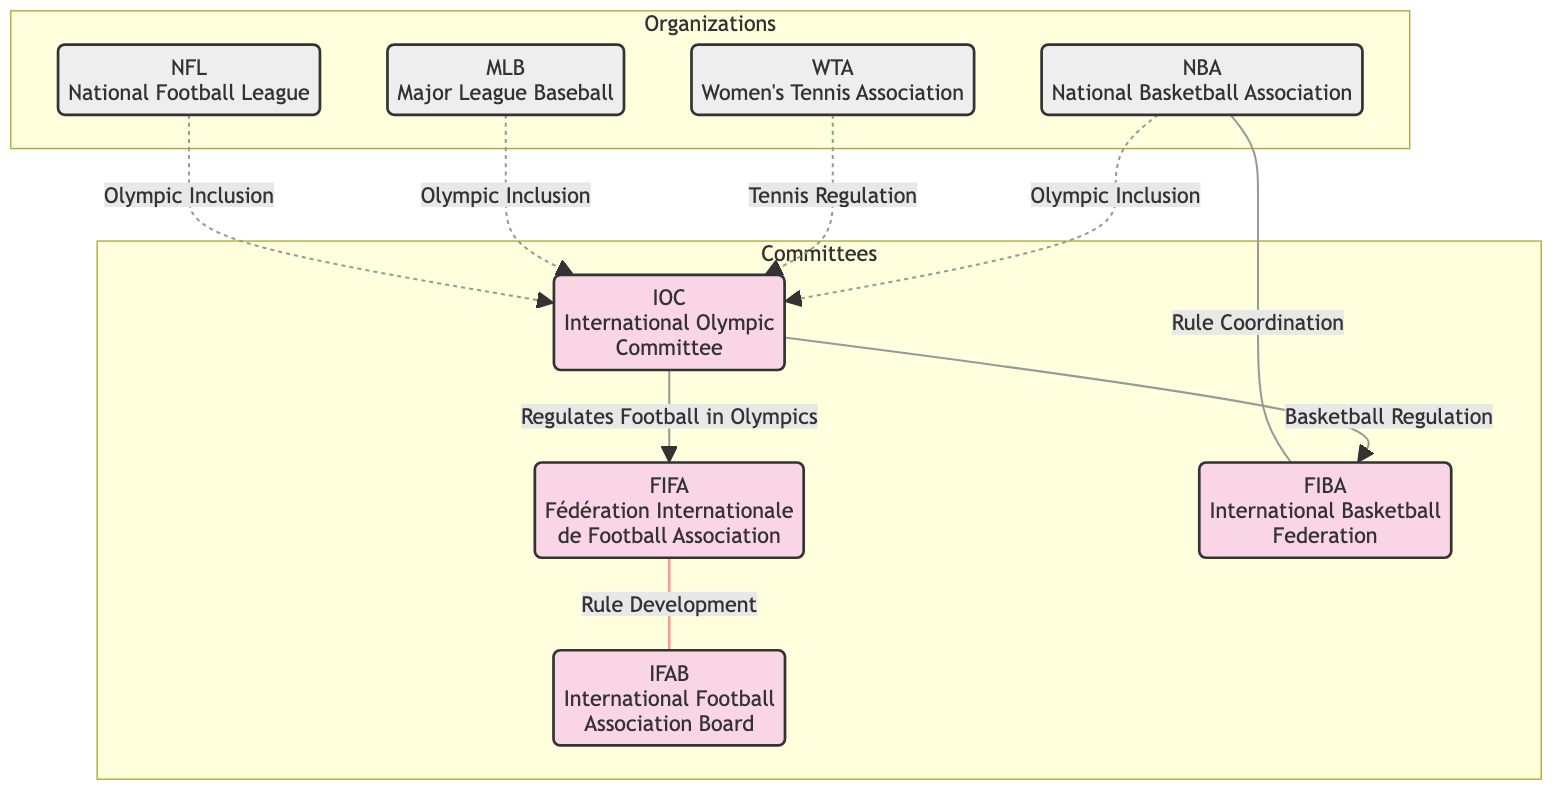What is the total number of nodes in the diagram? The diagram lists 8 distinct nodes, which include 4 committees and 4 organizations. Counting them gives us 1 (FIFA), 2 (IFAB), 3 (IOC), 4 (FIBA), 5 (NFL), 6 (MLB), 7 (WTA), and 8 (NBA).
Answer: 8 Which committee regulates football in the Olympics? The diagram shows an arrow from the IOC to FIFA with the label "Regulates Football in Olympics," indicating that the Olympic Committee oversees football regulations through FIFA.
Answer: FIFA What relationship exists between NBA and FIBA? The edge between NBA and FIBA is labeled "Rule Coordination," indicating that these two organizations are involved in coordinating rules. This can be determined by observing the direct connection labeled in the diagram.
Answer: Rule Coordination How many organizations have a relationship with the IOC? The edges connected to the IOC show that it has relationships with 4 organizations: NFL, MLB, WTA, and NBA. After examining the edges, I can count these relationships to reach the total.
Answer: 4 What is the relationship between WTA and IOC? The relationship between WTA and IOC is labeled "Tennis Regulation." This label can be found on the edge directly connecting the two nodes in the diagram.
Answer: Tennis Regulation Which organization has a direct connection to the IFAB? The IFAB is only connected to FIFA with the relation "Rule Development." Since there are no other edges directly connecting IFAB to any organization, FIFA is the only one.
Answer: FIFA Which committee handles basketball regulations in the context of the IOC? The diagram shows an arrow from the IOC to FIBA labeled "Basketball Regulation," indicating that FIBA is responsible for basketball regulations as per the directives of the IOC.
Answer: FIBA What type of committee is the IFAB? The IFAB is classified as a committee, which is indicated visually in the diagram's subgraph labeled "Committees." This classification allows us to categorize IFAB correctly.
Answer: Committee What is the relationship between FIFA and IFAB? The connection between FIFA and IFAB is labeled "Rule Development," meaning FIFA is involved in the development of rules in relation to IFAB. This label helps to clarify their specific interaction.
Answer: Rule Development 